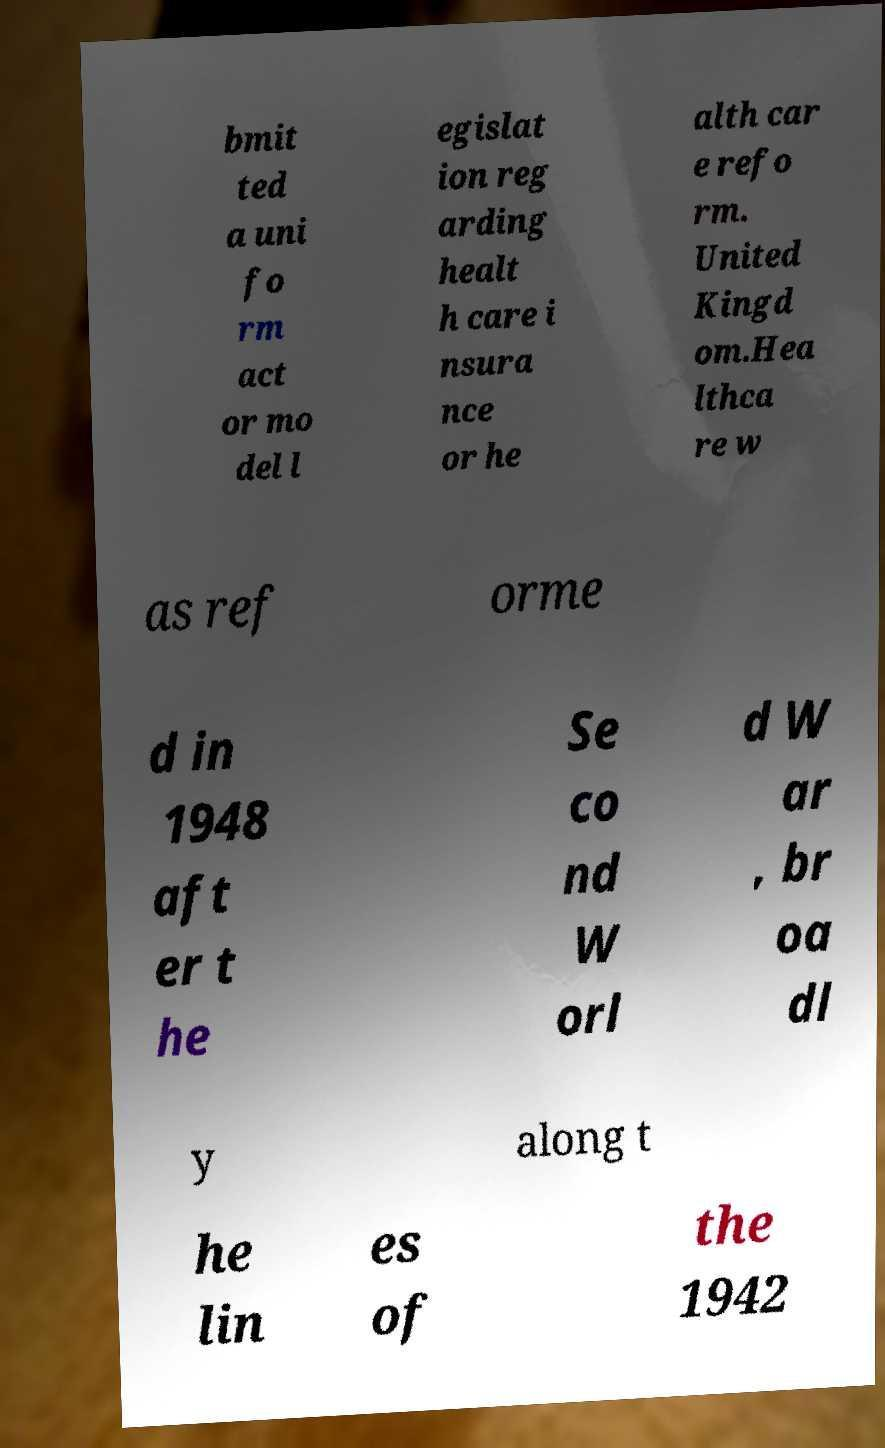Can you read and provide the text displayed in the image?This photo seems to have some interesting text. Can you extract and type it out for me? bmit ted a uni fo rm act or mo del l egislat ion reg arding healt h care i nsura nce or he alth car e refo rm. United Kingd om.Hea lthca re w as ref orme d in 1948 aft er t he Se co nd W orl d W ar , br oa dl y along t he lin es of the 1942 